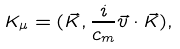<formula> <loc_0><loc_0><loc_500><loc_500>K _ { \mu } = ( \vec { K } , \frac { i } { c _ { m } } \vec { v } \cdot \vec { K } ) ,</formula> 